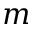Convert formula to latex. <formula><loc_0><loc_0><loc_500><loc_500>m</formula> 